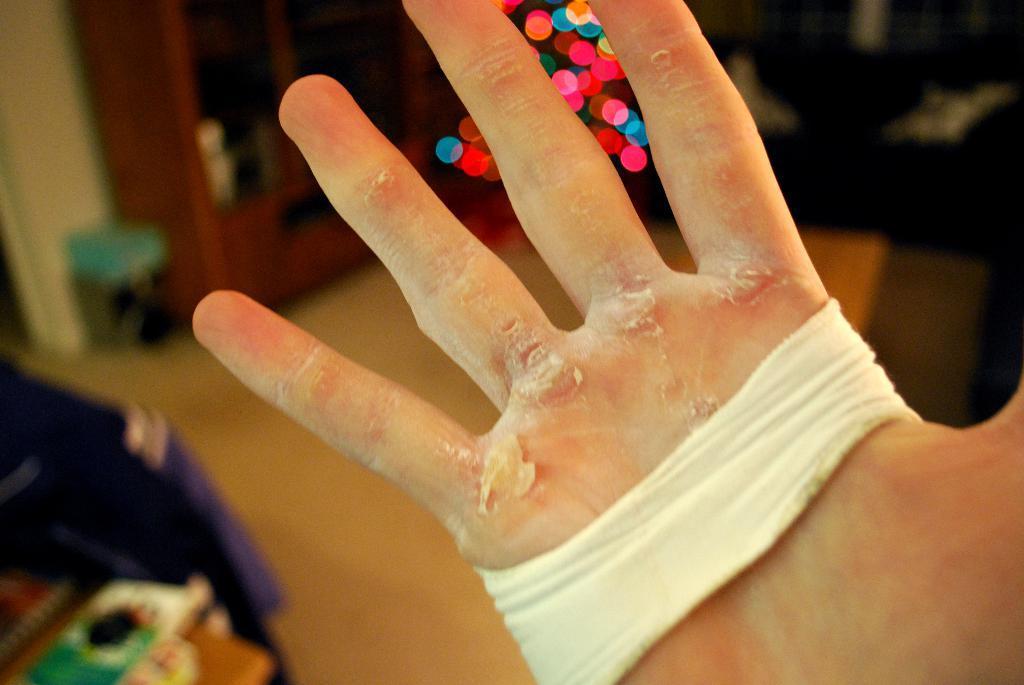How would you summarize this image in a sentence or two? In this picture we can see a fully injured hand of a person. 